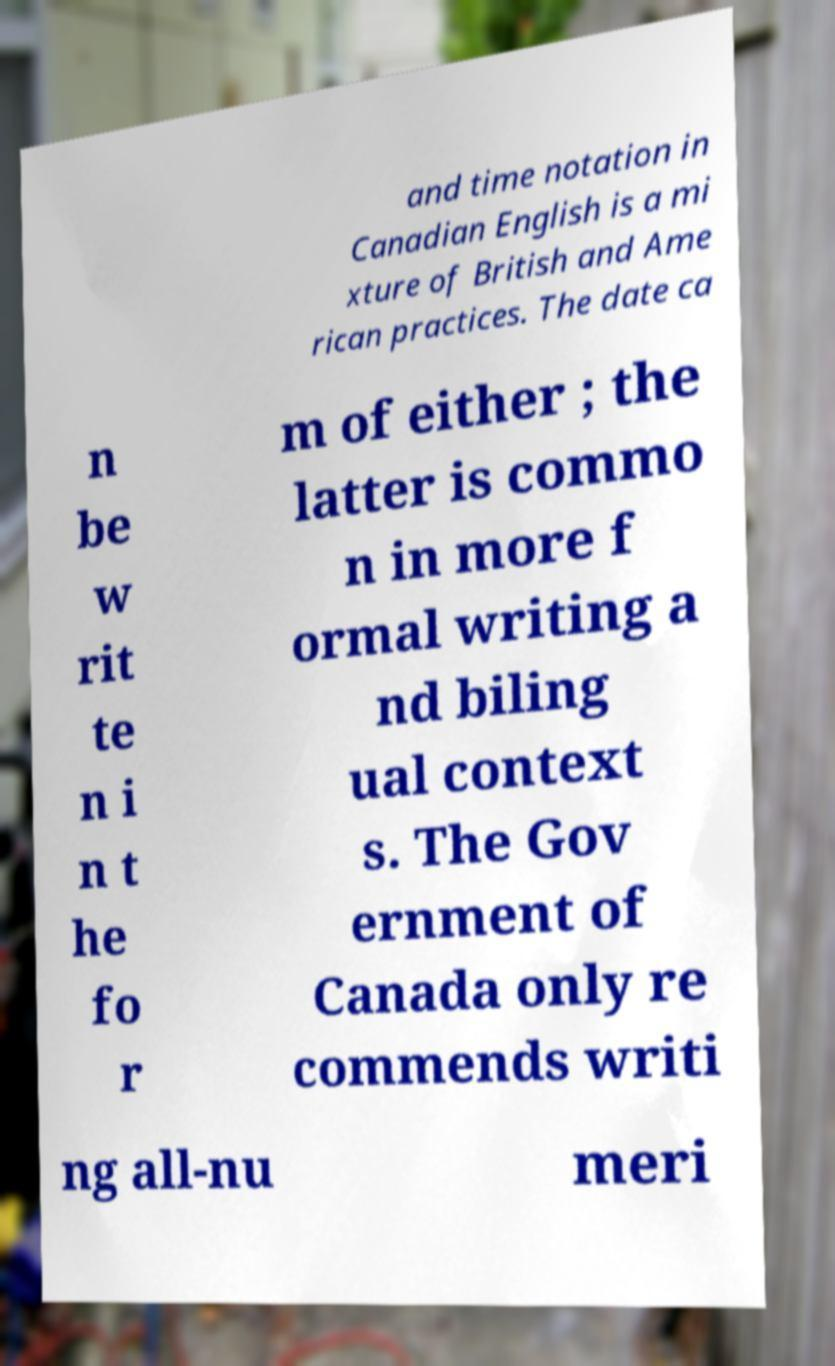Please identify and transcribe the text found in this image. and time notation in Canadian English is a mi xture of British and Ame rican practices. The date ca n be w rit te n i n t he fo r m of either ; the latter is commo n in more f ormal writing a nd biling ual context s. The Gov ernment of Canada only re commends writi ng all-nu meri 